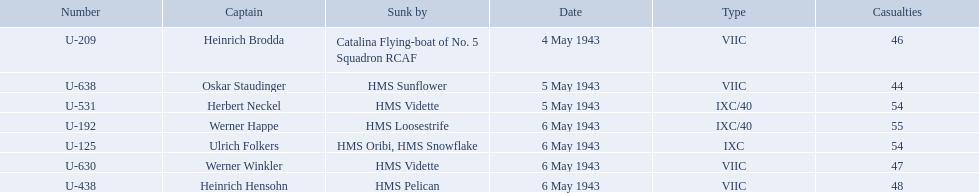What boats were lost on may 5? U-638, U-531. Who were the captains of those boats? Oskar Staudinger, Herbert Neckel. Which captain was not oskar staudinger? Herbert Neckel. 